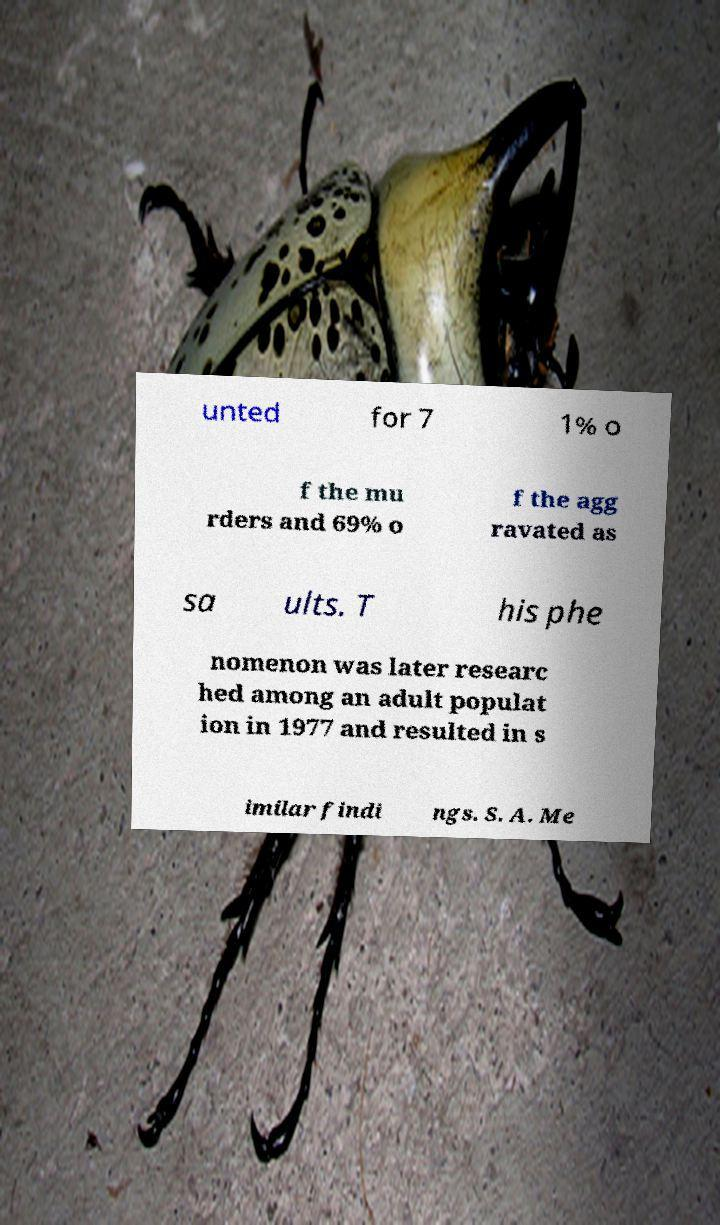Could you extract and type out the text from this image? unted for 7 1% o f the mu rders and 69% o f the agg ravated as sa ults. T his phe nomenon was later researc hed among an adult populat ion in 1977 and resulted in s imilar findi ngs. S. A. Me 